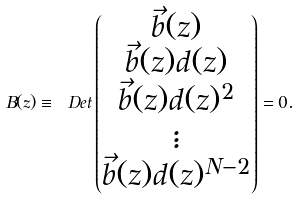Convert formula to latex. <formula><loc_0><loc_0><loc_500><loc_500>B ( z ) \equiv \ D e t \begin{pmatrix} \vec { b } ( z ) \\ \vec { b } ( z ) d ( z ) \\ \vec { b } ( z ) d ( z ) ^ { 2 } \\ \vdots \\ \vec { b } ( z ) d ( z ) ^ { N - 2 } \\ \end{pmatrix} = 0 .</formula> 